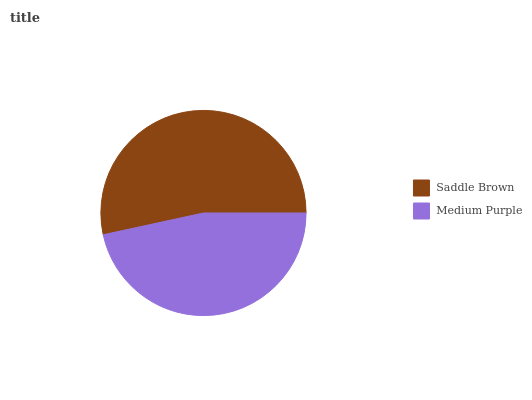Is Medium Purple the minimum?
Answer yes or no. Yes. Is Saddle Brown the maximum?
Answer yes or no. Yes. Is Medium Purple the maximum?
Answer yes or no. No. Is Saddle Brown greater than Medium Purple?
Answer yes or no. Yes. Is Medium Purple less than Saddle Brown?
Answer yes or no. Yes. Is Medium Purple greater than Saddle Brown?
Answer yes or no. No. Is Saddle Brown less than Medium Purple?
Answer yes or no. No. Is Saddle Brown the high median?
Answer yes or no. Yes. Is Medium Purple the low median?
Answer yes or no. Yes. Is Medium Purple the high median?
Answer yes or no. No. Is Saddle Brown the low median?
Answer yes or no. No. 